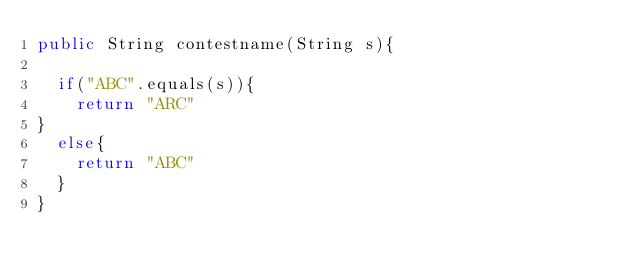<code> <loc_0><loc_0><loc_500><loc_500><_Java_>public String contestname(String s){

  if("ABC".equals(s)){
    return "ARC"
}
  else{
    return "ABC"
  }
}
  </code> 